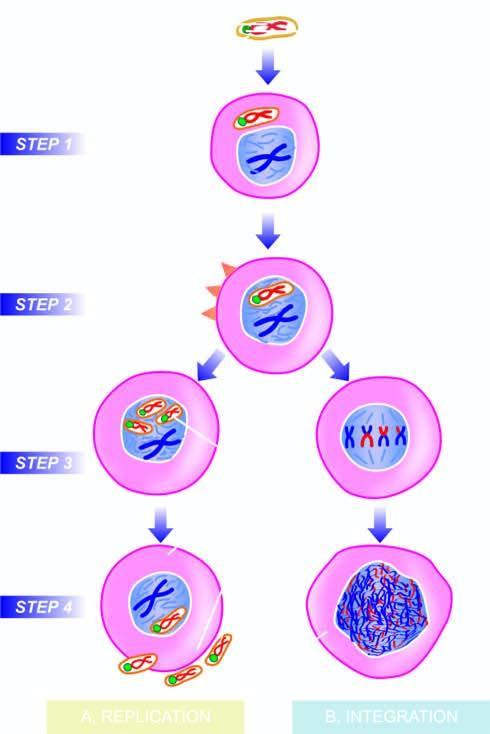what are the new virions assembled in?
Answer the question using a single word or phrase. Cell nucleus 